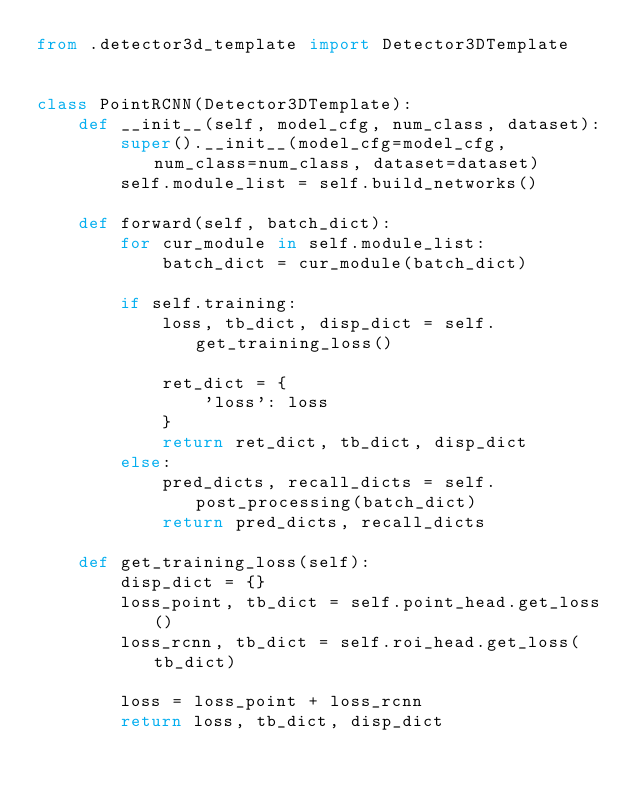<code> <loc_0><loc_0><loc_500><loc_500><_Python_>from .detector3d_template import Detector3DTemplate


class PointRCNN(Detector3DTemplate):
    def __init__(self, model_cfg, num_class, dataset):
        super().__init__(model_cfg=model_cfg, num_class=num_class, dataset=dataset)
        self.module_list = self.build_networks()
    
    def forward(self, batch_dict):
        for cur_module in self.module_list:
            batch_dict = cur_module(batch_dict)
        
        if self.training:
            loss, tb_dict, disp_dict = self.get_training_loss()
            
            ret_dict = {
                'loss': loss
            }
            return ret_dict, tb_dict, disp_dict
        else:
            pred_dicts, recall_dicts = self.post_processing(batch_dict)
            return pred_dicts, recall_dicts
    
    def get_training_loss(self):
        disp_dict = {}
        loss_point, tb_dict = self.point_head.get_loss()
        loss_rcnn, tb_dict = self.roi_head.get_loss(tb_dict)
        
        loss = loss_point + loss_rcnn
        return loss, tb_dict, disp_dict
</code> 